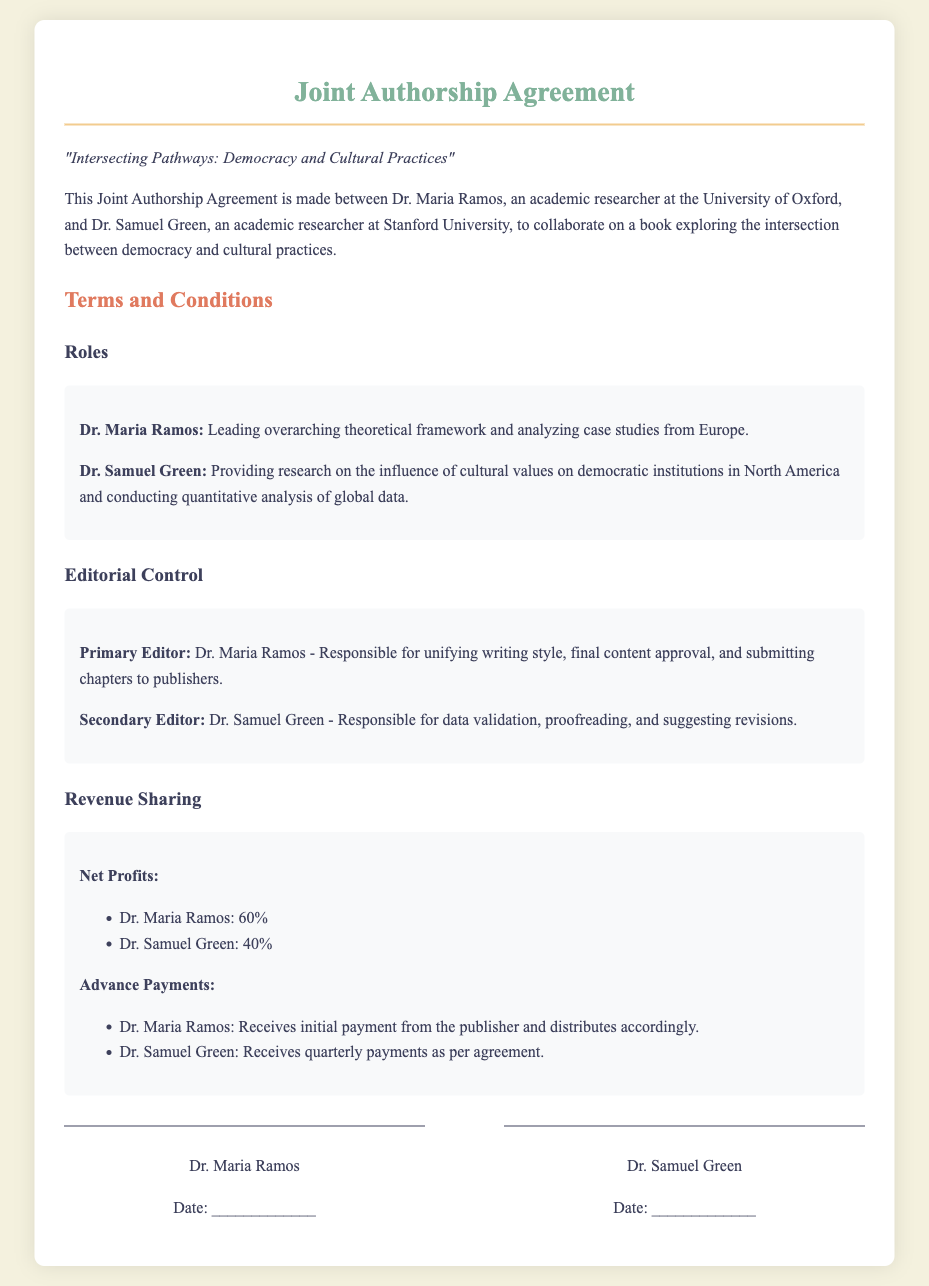What are the authors' names? Dr. Maria Ramos and Dr. Samuel Green are the collaborators.
Answer: Dr. Maria Ramos and Dr. Samuel Green What is the title of the book? The title is mentioned in the introduction to the agreement.
Answer: Intersecting Pathways: Democracy and Cultural Practices Who is the primary editor? This role is specified in the editorial control section.
Answer: Dr. Maria Ramos What percentage of net profits does Dr. Samuel Green receive? The revenue sharing section outlines the profit distribution.
Answer: 40% What is Dr. Maria Ramos's responsibility in the editorial process? Her responsibilities are detailed under the editorial control section.
Answer: Unifying writing style, final content approval, and submitting chapters to publishers What type of analysis does Dr. Samuel Green conduct? This is found in the roles section of the agreement.
Answer: Quantitative analysis of global data What is Dr. Maria Ramos's role regarding case studies? The document specifies her contribution in the roles section.
Answer: Analyzing case studies from Europe How are advance payments distributed? This information is provided in the revenue sharing section.
Answer: Dr. Maria Ramos receives initial payment from the publisher and distributes accordingly What is the date format for signatures in the document? The signature section shows how the date should be recorded.
Answer: _____________ 